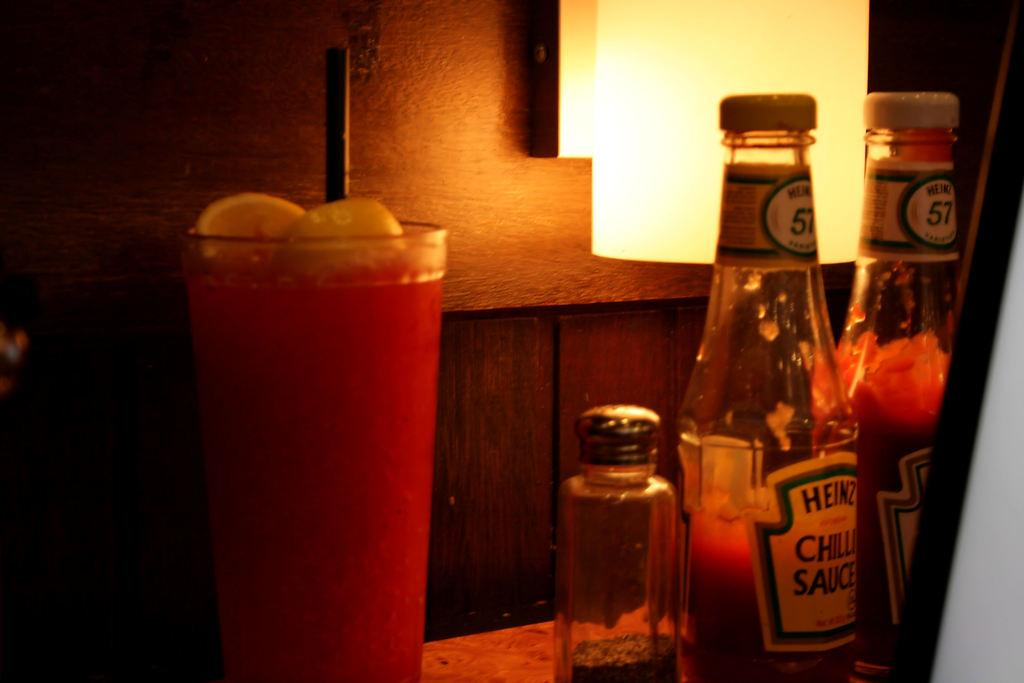Provide a one-sentence caption for the provided image. A bottle of Heinz ketchup next to a drink. 